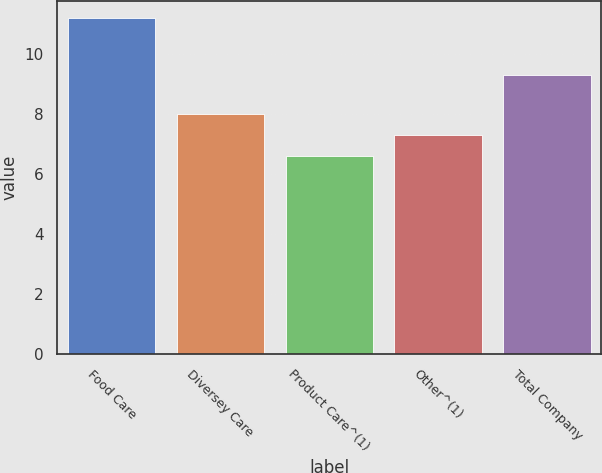Convert chart to OTSL. <chart><loc_0><loc_0><loc_500><loc_500><bar_chart><fcel>Food Care<fcel>Diversey Care<fcel>Product Care^(1)<fcel>Other^(1)<fcel>Total Company<nl><fcel>11.2<fcel>8<fcel>6.6<fcel>7.3<fcel>9.3<nl></chart> 